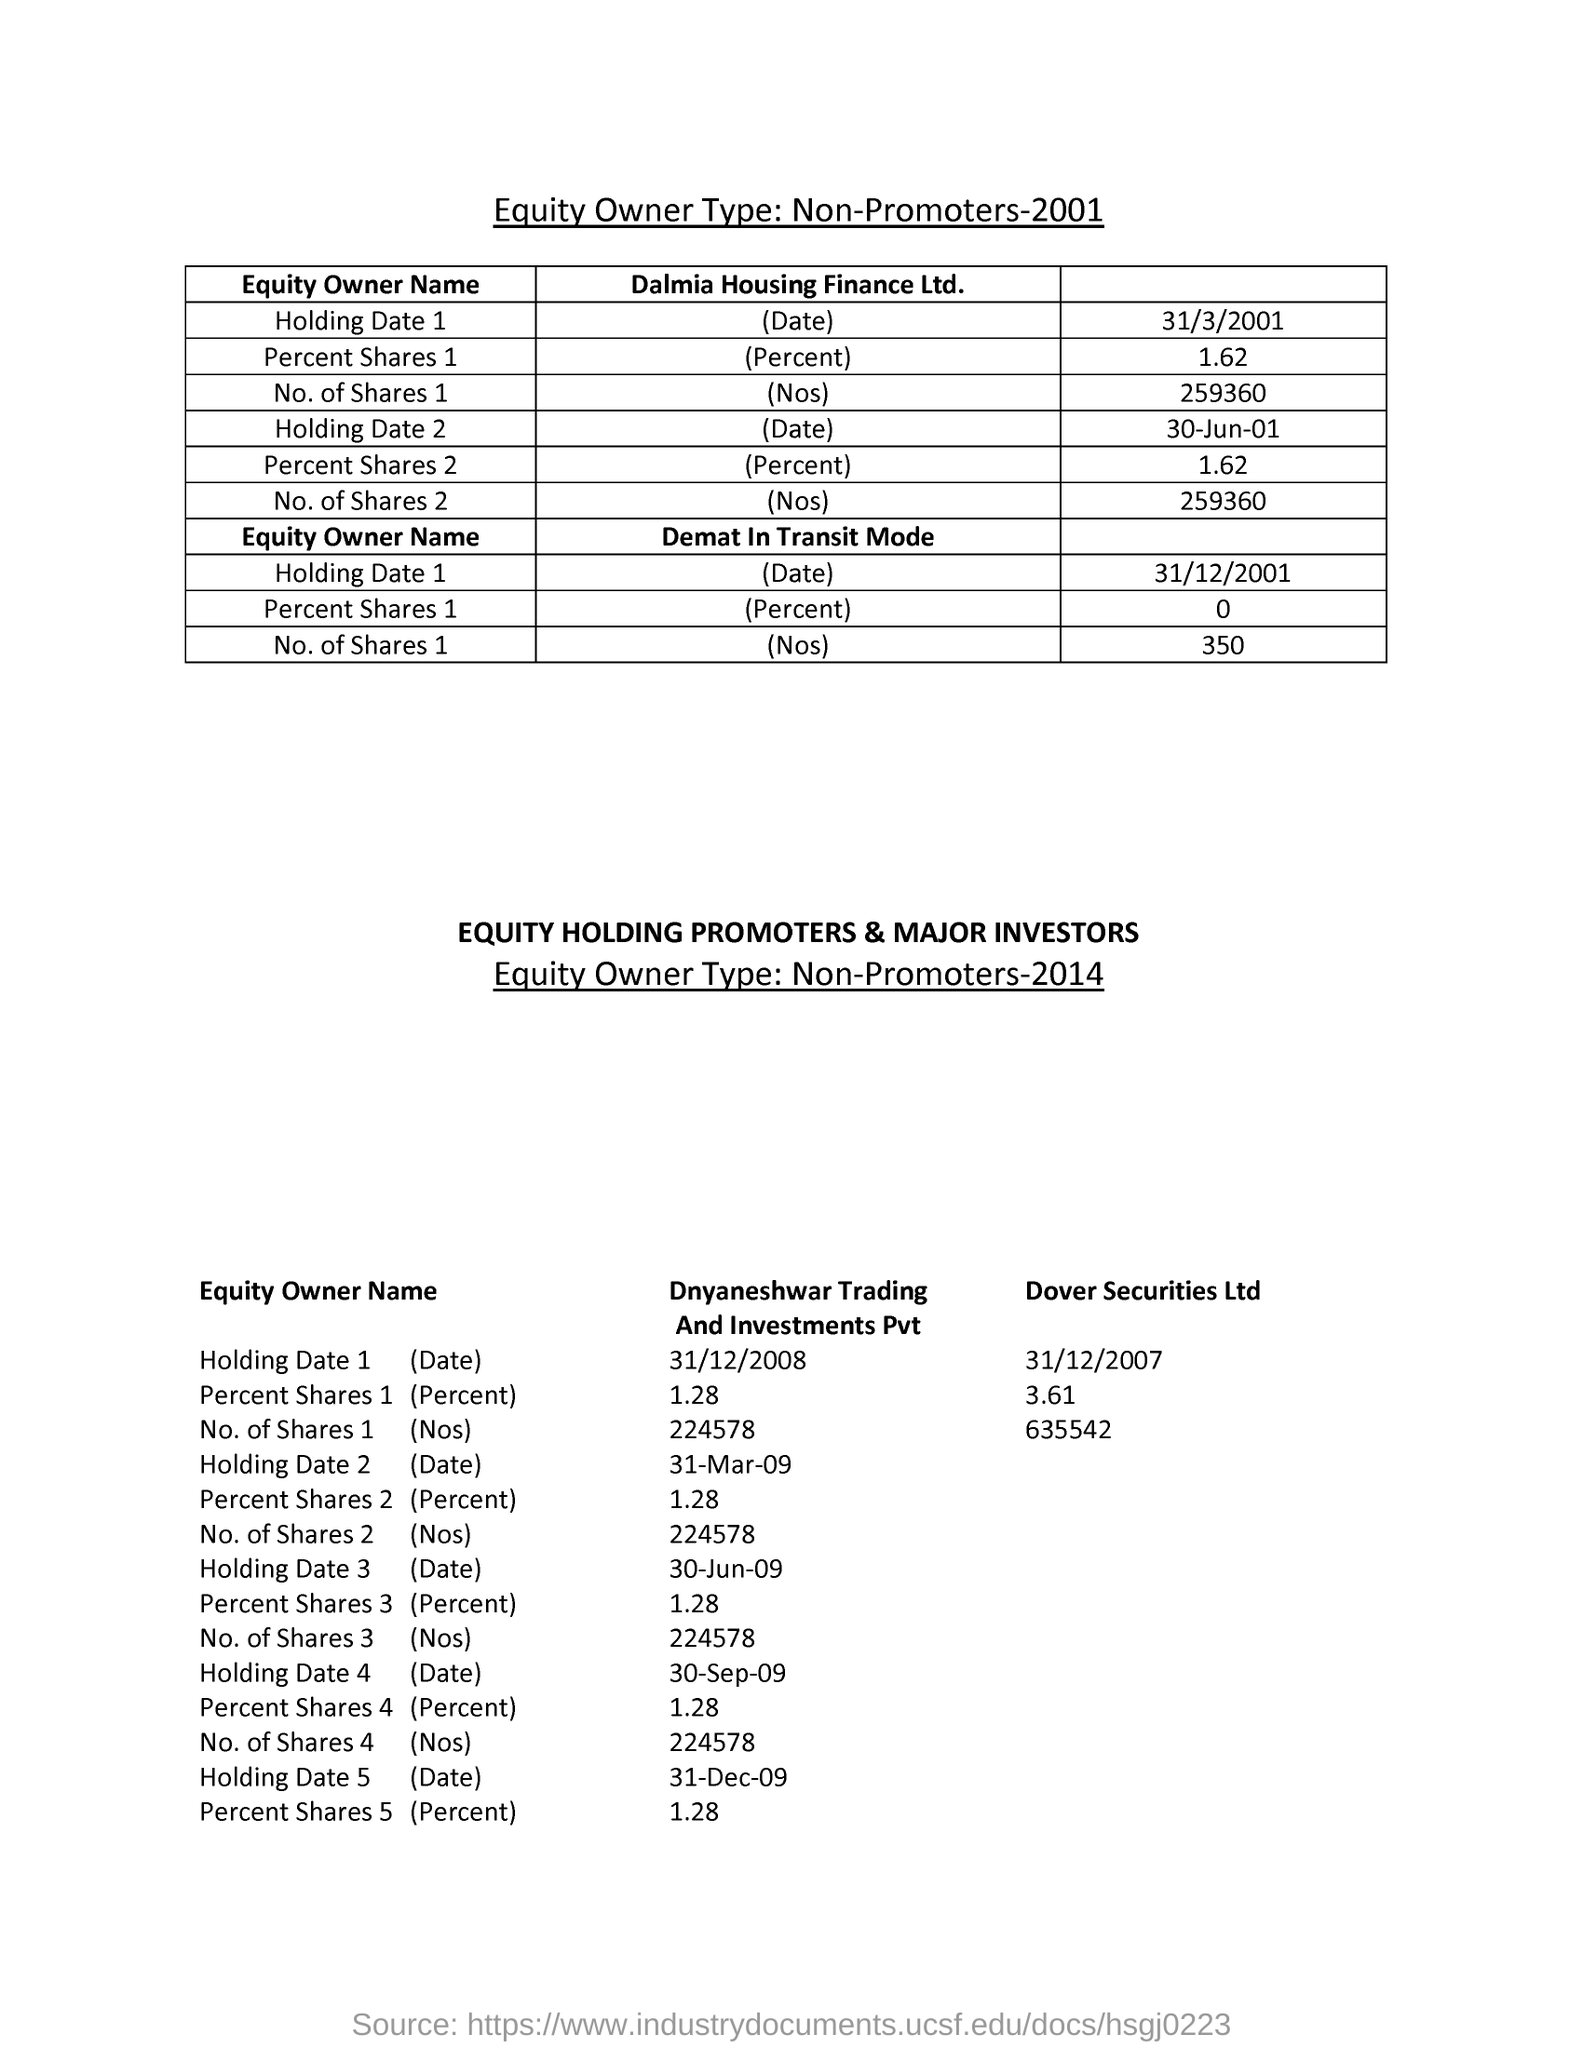Mention a couple of crucial points in this snapshot. The holding date for Dover Securities Ltd on December 31st, 2007 is... Dalmia Housing Finance Ltd. has 259,360 shares outstanding. Dover Securities Ltd has 635,542 shares. The Percent Shares 2 for Dnyaneshwar Trading And Investments  Pvt is 1.28%. The percentage of shares for Dalmia Housing Finance Ltd. is 1.62%. 